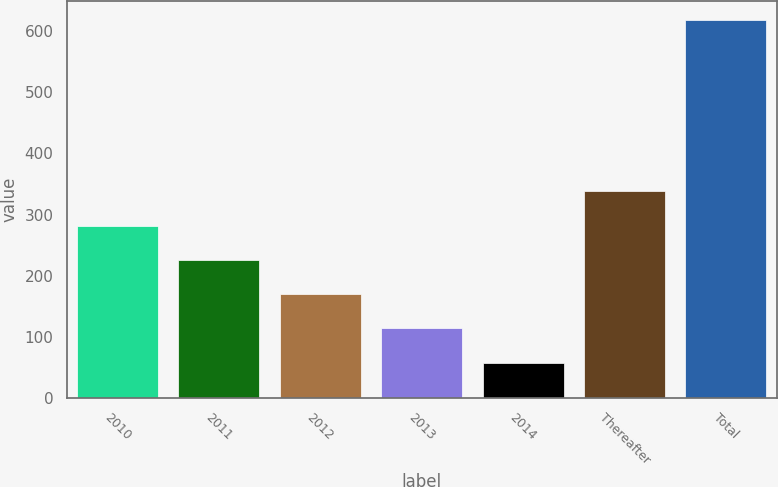Convert chart. <chart><loc_0><loc_0><loc_500><loc_500><bar_chart><fcel>2010<fcel>2011<fcel>2012<fcel>2013<fcel>2014<fcel>Thereafter<fcel>Total<nl><fcel>282<fcel>226<fcel>170<fcel>114<fcel>58<fcel>338<fcel>618<nl></chart> 